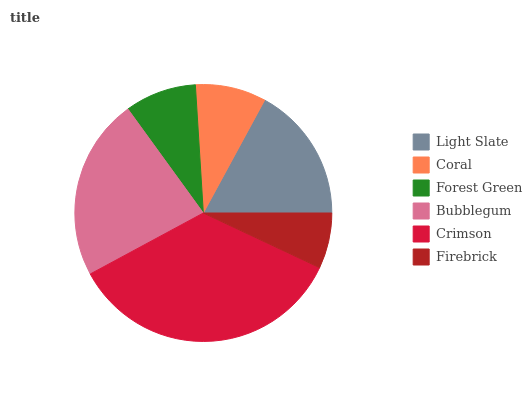Is Firebrick the minimum?
Answer yes or no. Yes. Is Crimson the maximum?
Answer yes or no. Yes. Is Coral the minimum?
Answer yes or no. No. Is Coral the maximum?
Answer yes or no. No. Is Light Slate greater than Coral?
Answer yes or no. Yes. Is Coral less than Light Slate?
Answer yes or no. Yes. Is Coral greater than Light Slate?
Answer yes or no. No. Is Light Slate less than Coral?
Answer yes or no. No. Is Light Slate the high median?
Answer yes or no. Yes. Is Forest Green the low median?
Answer yes or no. Yes. Is Forest Green the high median?
Answer yes or no. No. Is Coral the low median?
Answer yes or no. No. 